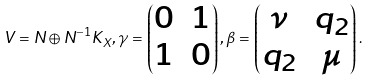<formula> <loc_0><loc_0><loc_500><loc_500>V = N \oplus N ^ { - 1 } K _ { X } , \gamma = \begin{pmatrix} 0 & 1 \\ 1 & 0 \end{pmatrix} , \beta = \begin{pmatrix} \nu & q _ { 2 } \\ q _ { 2 } & \mu \end{pmatrix} .</formula> 